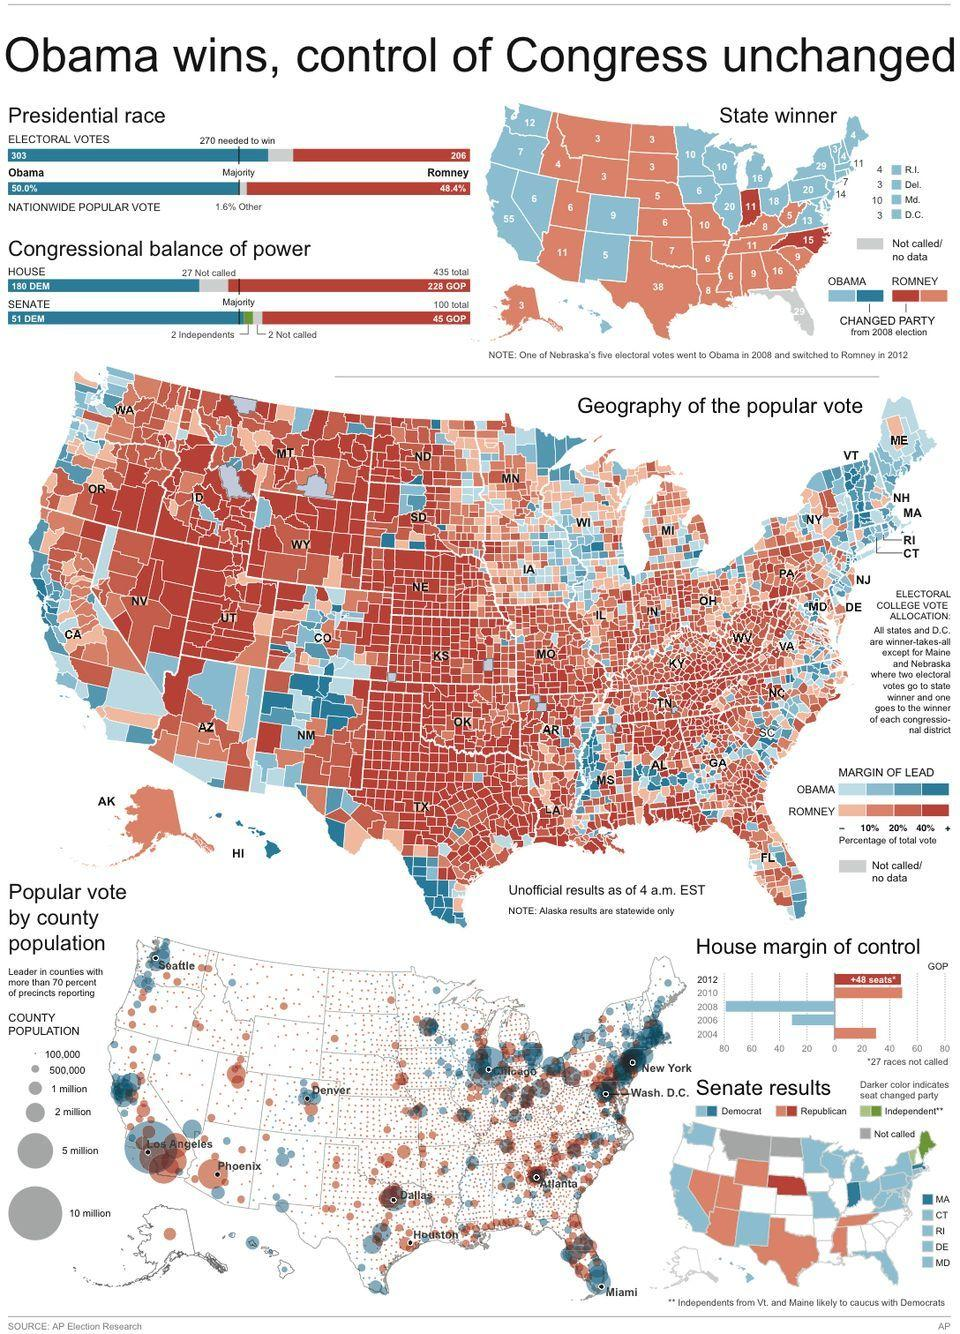Specify some key components in this picture. The Republican party is commonly represented by the color red. The green party is represented by the party named "Independent. Barack Obama received 97 more electoral votes than Mitt Romney in the 2012 presidential election. In the 2012 presidential election, Barack Obama won the nationwide popular vote by 1.6% over his opponent, Mitt Romney. 